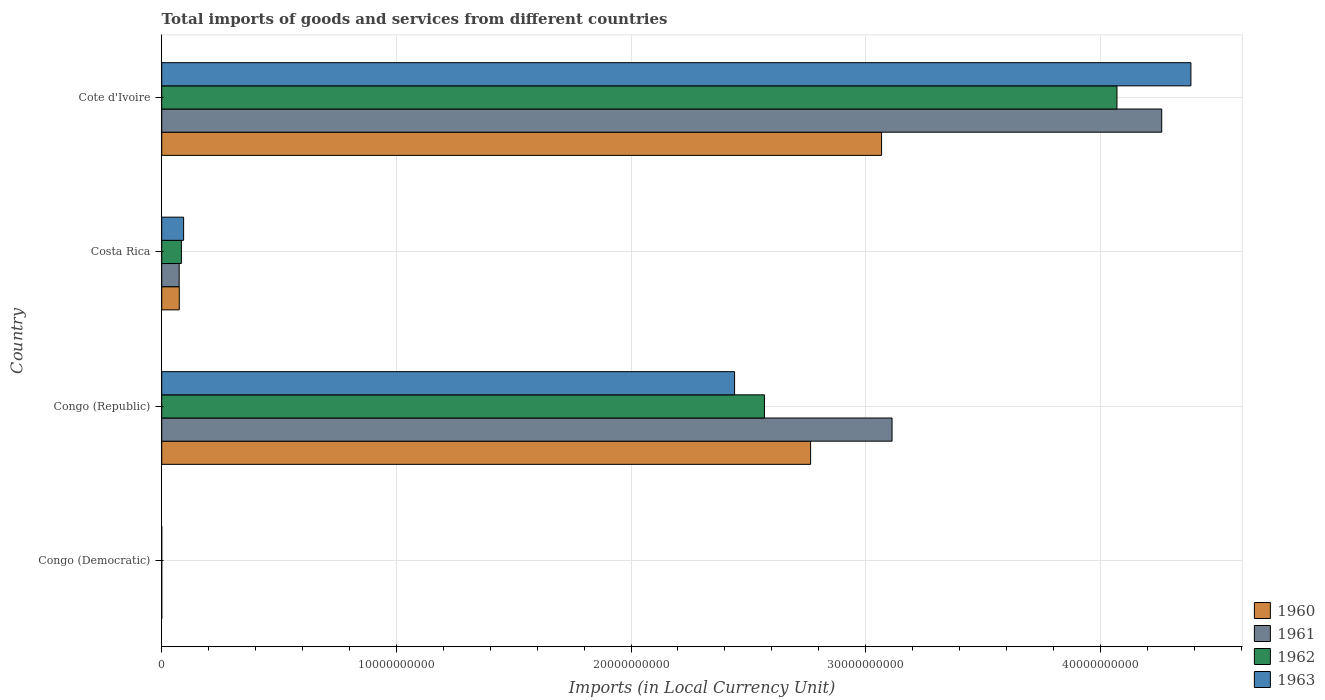How many groups of bars are there?
Your response must be concise. 4. Are the number of bars on each tick of the Y-axis equal?
Your answer should be very brief. Yes. How many bars are there on the 2nd tick from the top?
Offer a very short reply. 4. How many bars are there on the 1st tick from the bottom?
Your response must be concise. 4. What is the label of the 2nd group of bars from the top?
Your answer should be compact. Costa Rica. What is the Amount of goods and services imports in 1960 in Costa Rica?
Your answer should be very brief. 7.49e+08. Across all countries, what is the maximum Amount of goods and services imports in 1962?
Your response must be concise. 4.07e+1. Across all countries, what is the minimum Amount of goods and services imports in 1963?
Make the answer very short. 0. In which country was the Amount of goods and services imports in 1960 maximum?
Your answer should be compact. Cote d'Ivoire. In which country was the Amount of goods and services imports in 1963 minimum?
Offer a very short reply. Congo (Democratic). What is the total Amount of goods and services imports in 1960 in the graph?
Offer a terse response. 5.91e+1. What is the difference between the Amount of goods and services imports in 1963 in Congo (Republic) and that in Costa Rica?
Keep it short and to the point. 2.35e+1. What is the difference between the Amount of goods and services imports in 1961 in Congo (Republic) and the Amount of goods and services imports in 1962 in Costa Rica?
Ensure brevity in your answer.  3.03e+1. What is the average Amount of goods and services imports in 1960 per country?
Offer a very short reply. 1.48e+1. What is the difference between the Amount of goods and services imports in 1960 and Amount of goods and services imports in 1962 in Cote d'Ivoire?
Give a very brief answer. -1.00e+1. In how many countries, is the Amount of goods and services imports in 1960 greater than 20000000000 LCU?
Provide a short and direct response. 2. What is the ratio of the Amount of goods and services imports in 1962 in Congo (Democratic) to that in Cote d'Ivoire?
Provide a short and direct response. 1.4510167605346176e-15. Is the difference between the Amount of goods and services imports in 1960 in Congo (Republic) and Costa Rica greater than the difference between the Amount of goods and services imports in 1962 in Congo (Republic) and Costa Rica?
Your answer should be compact. Yes. What is the difference between the highest and the second highest Amount of goods and services imports in 1963?
Offer a terse response. 1.94e+1. What is the difference between the highest and the lowest Amount of goods and services imports in 1961?
Ensure brevity in your answer.  4.26e+1. In how many countries, is the Amount of goods and services imports in 1961 greater than the average Amount of goods and services imports in 1961 taken over all countries?
Keep it short and to the point. 2. What does the 1st bar from the bottom in Cote d'Ivoire represents?
Your response must be concise. 1960. How many bars are there?
Make the answer very short. 16. How many countries are there in the graph?
Offer a very short reply. 4. What is the difference between two consecutive major ticks on the X-axis?
Make the answer very short. 1.00e+1. Are the values on the major ticks of X-axis written in scientific E-notation?
Give a very brief answer. No. How are the legend labels stacked?
Ensure brevity in your answer.  Vertical. What is the title of the graph?
Your response must be concise. Total imports of goods and services from different countries. Does "1977" appear as one of the legend labels in the graph?
Offer a terse response. No. What is the label or title of the X-axis?
Make the answer very short. Imports (in Local Currency Unit). What is the label or title of the Y-axis?
Your answer should be very brief. Country. What is the Imports (in Local Currency Unit) in 1960 in Congo (Democratic)?
Offer a terse response. 0. What is the Imports (in Local Currency Unit) of 1961 in Congo (Democratic)?
Provide a short and direct response. 5.07076656504069e-5. What is the Imports (in Local Currency Unit) in 1962 in Congo (Democratic)?
Ensure brevity in your answer.  5.906629303353841e-5. What is the Imports (in Local Currency Unit) in 1963 in Congo (Democratic)?
Offer a very short reply. 0. What is the Imports (in Local Currency Unit) in 1960 in Congo (Republic)?
Offer a terse response. 2.77e+1. What is the Imports (in Local Currency Unit) of 1961 in Congo (Republic)?
Provide a succinct answer. 3.11e+1. What is the Imports (in Local Currency Unit) of 1962 in Congo (Republic)?
Make the answer very short. 2.57e+1. What is the Imports (in Local Currency Unit) of 1963 in Congo (Republic)?
Provide a succinct answer. 2.44e+1. What is the Imports (in Local Currency Unit) of 1960 in Costa Rica?
Your answer should be very brief. 7.49e+08. What is the Imports (in Local Currency Unit) in 1961 in Costa Rica?
Provide a short and direct response. 7.44e+08. What is the Imports (in Local Currency Unit) of 1962 in Costa Rica?
Make the answer very short. 8.40e+08. What is the Imports (in Local Currency Unit) of 1963 in Costa Rica?
Your answer should be compact. 9.34e+08. What is the Imports (in Local Currency Unit) in 1960 in Cote d'Ivoire?
Offer a very short reply. 3.07e+1. What is the Imports (in Local Currency Unit) of 1961 in Cote d'Ivoire?
Make the answer very short. 4.26e+1. What is the Imports (in Local Currency Unit) of 1962 in Cote d'Ivoire?
Give a very brief answer. 4.07e+1. What is the Imports (in Local Currency Unit) of 1963 in Cote d'Ivoire?
Your answer should be compact. 4.39e+1. Across all countries, what is the maximum Imports (in Local Currency Unit) of 1960?
Provide a short and direct response. 3.07e+1. Across all countries, what is the maximum Imports (in Local Currency Unit) in 1961?
Your answer should be very brief. 4.26e+1. Across all countries, what is the maximum Imports (in Local Currency Unit) of 1962?
Ensure brevity in your answer.  4.07e+1. Across all countries, what is the maximum Imports (in Local Currency Unit) of 1963?
Your answer should be very brief. 4.39e+1. Across all countries, what is the minimum Imports (in Local Currency Unit) in 1960?
Your answer should be compact. 0. Across all countries, what is the minimum Imports (in Local Currency Unit) in 1961?
Make the answer very short. 5.07076656504069e-5. Across all countries, what is the minimum Imports (in Local Currency Unit) of 1962?
Ensure brevity in your answer.  5.906629303353841e-5. Across all countries, what is the minimum Imports (in Local Currency Unit) of 1963?
Your response must be concise. 0. What is the total Imports (in Local Currency Unit) in 1960 in the graph?
Your answer should be compact. 5.91e+1. What is the total Imports (in Local Currency Unit) in 1961 in the graph?
Give a very brief answer. 7.45e+1. What is the total Imports (in Local Currency Unit) in 1962 in the graph?
Keep it short and to the point. 6.72e+1. What is the total Imports (in Local Currency Unit) in 1963 in the graph?
Ensure brevity in your answer.  6.92e+1. What is the difference between the Imports (in Local Currency Unit) of 1960 in Congo (Democratic) and that in Congo (Republic)?
Give a very brief answer. -2.77e+1. What is the difference between the Imports (in Local Currency Unit) of 1961 in Congo (Democratic) and that in Congo (Republic)?
Keep it short and to the point. -3.11e+1. What is the difference between the Imports (in Local Currency Unit) in 1962 in Congo (Democratic) and that in Congo (Republic)?
Your answer should be very brief. -2.57e+1. What is the difference between the Imports (in Local Currency Unit) of 1963 in Congo (Democratic) and that in Congo (Republic)?
Your answer should be compact. -2.44e+1. What is the difference between the Imports (in Local Currency Unit) in 1960 in Congo (Democratic) and that in Costa Rica?
Provide a succinct answer. -7.49e+08. What is the difference between the Imports (in Local Currency Unit) of 1961 in Congo (Democratic) and that in Costa Rica?
Give a very brief answer. -7.44e+08. What is the difference between the Imports (in Local Currency Unit) of 1962 in Congo (Democratic) and that in Costa Rica?
Provide a succinct answer. -8.40e+08. What is the difference between the Imports (in Local Currency Unit) of 1963 in Congo (Democratic) and that in Costa Rica?
Provide a succinct answer. -9.34e+08. What is the difference between the Imports (in Local Currency Unit) of 1960 in Congo (Democratic) and that in Cote d'Ivoire?
Provide a succinct answer. -3.07e+1. What is the difference between the Imports (in Local Currency Unit) of 1961 in Congo (Democratic) and that in Cote d'Ivoire?
Provide a short and direct response. -4.26e+1. What is the difference between the Imports (in Local Currency Unit) in 1962 in Congo (Democratic) and that in Cote d'Ivoire?
Provide a short and direct response. -4.07e+1. What is the difference between the Imports (in Local Currency Unit) in 1963 in Congo (Democratic) and that in Cote d'Ivoire?
Your answer should be very brief. -4.39e+1. What is the difference between the Imports (in Local Currency Unit) of 1960 in Congo (Republic) and that in Costa Rica?
Your response must be concise. 2.69e+1. What is the difference between the Imports (in Local Currency Unit) of 1961 in Congo (Republic) and that in Costa Rica?
Give a very brief answer. 3.04e+1. What is the difference between the Imports (in Local Currency Unit) in 1962 in Congo (Republic) and that in Costa Rica?
Provide a succinct answer. 2.48e+1. What is the difference between the Imports (in Local Currency Unit) of 1963 in Congo (Republic) and that in Costa Rica?
Your answer should be compact. 2.35e+1. What is the difference between the Imports (in Local Currency Unit) of 1960 in Congo (Republic) and that in Cote d'Ivoire?
Your response must be concise. -3.02e+09. What is the difference between the Imports (in Local Currency Unit) of 1961 in Congo (Republic) and that in Cote d'Ivoire?
Your answer should be compact. -1.15e+1. What is the difference between the Imports (in Local Currency Unit) of 1962 in Congo (Republic) and that in Cote d'Ivoire?
Offer a terse response. -1.50e+1. What is the difference between the Imports (in Local Currency Unit) of 1963 in Congo (Republic) and that in Cote d'Ivoire?
Give a very brief answer. -1.94e+1. What is the difference between the Imports (in Local Currency Unit) of 1960 in Costa Rica and that in Cote d'Ivoire?
Make the answer very short. -2.99e+1. What is the difference between the Imports (in Local Currency Unit) of 1961 in Costa Rica and that in Cote d'Ivoire?
Offer a very short reply. -4.19e+1. What is the difference between the Imports (in Local Currency Unit) of 1962 in Costa Rica and that in Cote d'Ivoire?
Your response must be concise. -3.99e+1. What is the difference between the Imports (in Local Currency Unit) of 1963 in Costa Rica and that in Cote d'Ivoire?
Keep it short and to the point. -4.29e+1. What is the difference between the Imports (in Local Currency Unit) in 1960 in Congo (Democratic) and the Imports (in Local Currency Unit) in 1961 in Congo (Republic)?
Give a very brief answer. -3.11e+1. What is the difference between the Imports (in Local Currency Unit) in 1960 in Congo (Democratic) and the Imports (in Local Currency Unit) in 1962 in Congo (Republic)?
Keep it short and to the point. -2.57e+1. What is the difference between the Imports (in Local Currency Unit) of 1960 in Congo (Democratic) and the Imports (in Local Currency Unit) of 1963 in Congo (Republic)?
Make the answer very short. -2.44e+1. What is the difference between the Imports (in Local Currency Unit) in 1961 in Congo (Democratic) and the Imports (in Local Currency Unit) in 1962 in Congo (Republic)?
Your response must be concise. -2.57e+1. What is the difference between the Imports (in Local Currency Unit) of 1961 in Congo (Democratic) and the Imports (in Local Currency Unit) of 1963 in Congo (Republic)?
Provide a short and direct response. -2.44e+1. What is the difference between the Imports (in Local Currency Unit) of 1962 in Congo (Democratic) and the Imports (in Local Currency Unit) of 1963 in Congo (Republic)?
Your answer should be very brief. -2.44e+1. What is the difference between the Imports (in Local Currency Unit) of 1960 in Congo (Democratic) and the Imports (in Local Currency Unit) of 1961 in Costa Rica?
Provide a succinct answer. -7.44e+08. What is the difference between the Imports (in Local Currency Unit) in 1960 in Congo (Democratic) and the Imports (in Local Currency Unit) in 1962 in Costa Rica?
Ensure brevity in your answer.  -8.40e+08. What is the difference between the Imports (in Local Currency Unit) of 1960 in Congo (Democratic) and the Imports (in Local Currency Unit) of 1963 in Costa Rica?
Your answer should be compact. -9.34e+08. What is the difference between the Imports (in Local Currency Unit) of 1961 in Congo (Democratic) and the Imports (in Local Currency Unit) of 1962 in Costa Rica?
Provide a short and direct response. -8.40e+08. What is the difference between the Imports (in Local Currency Unit) in 1961 in Congo (Democratic) and the Imports (in Local Currency Unit) in 1963 in Costa Rica?
Provide a short and direct response. -9.34e+08. What is the difference between the Imports (in Local Currency Unit) of 1962 in Congo (Democratic) and the Imports (in Local Currency Unit) of 1963 in Costa Rica?
Make the answer very short. -9.34e+08. What is the difference between the Imports (in Local Currency Unit) in 1960 in Congo (Democratic) and the Imports (in Local Currency Unit) in 1961 in Cote d'Ivoire?
Provide a short and direct response. -4.26e+1. What is the difference between the Imports (in Local Currency Unit) of 1960 in Congo (Democratic) and the Imports (in Local Currency Unit) of 1962 in Cote d'Ivoire?
Provide a succinct answer. -4.07e+1. What is the difference between the Imports (in Local Currency Unit) in 1960 in Congo (Democratic) and the Imports (in Local Currency Unit) in 1963 in Cote d'Ivoire?
Provide a short and direct response. -4.39e+1. What is the difference between the Imports (in Local Currency Unit) of 1961 in Congo (Democratic) and the Imports (in Local Currency Unit) of 1962 in Cote d'Ivoire?
Give a very brief answer. -4.07e+1. What is the difference between the Imports (in Local Currency Unit) of 1961 in Congo (Democratic) and the Imports (in Local Currency Unit) of 1963 in Cote d'Ivoire?
Offer a very short reply. -4.39e+1. What is the difference between the Imports (in Local Currency Unit) in 1962 in Congo (Democratic) and the Imports (in Local Currency Unit) in 1963 in Cote d'Ivoire?
Ensure brevity in your answer.  -4.39e+1. What is the difference between the Imports (in Local Currency Unit) of 1960 in Congo (Republic) and the Imports (in Local Currency Unit) of 1961 in Costa Rica?
Keep it short and to the point. 2.69e+1. What is the difference between the Imports (in Local Currency Unit) of 1960 in Congo (Republic) and the Imports (in Local Currency Unit) of 1962 in Costa Rica?
Give a very brief answer. 2.68e+1. What is the difference between the Imports (in Local Currency Unit) in 1960 in Congo (Republic) and the Imports (in Local Currency Unit) in 1963 in Costa Rica?
Give a very brief answer. 2.67e+1. What is the difference between the Imports (in Local Currency Unit) in 1961 in Congo (Republic) and the Imports (in Local Currency Unit) in 1962 in Costa Rica?
Offer a very short reply. 3.03e+1. What is the difference between the Imports (in Local Currency Unit) in 1961 in Congo (Republic) and the Imports (in Local Currency Unit) in 1963 in Costa Rica?
Give a very brief answer. 3.02e+1. What is the difference between the Imports (in Local Currency Unit) in 1962 in Congo (Republic) and the Imports (in Local Currency Unit) in 1963 in Costa Rica?
Ensure brevity in your answer.  2.48e+1. What is the difference between the Imports (in Local Currency Unit) of 1960 in Congo (Republic) and the Imports (in Local Currency Unit) of 1961 in Cote d'Ivoire?
Ensure brevity in your answer.  -1.50e+1. What is the difference between the Imports (in Local Currency Unit) of 1960 in Congo (Republic) and the Imports (in Local Currency Unit) of 1962 in Cote d'Ivoire?
Provide a short and direct response. -1.31e+1. What is the difference between the Imports (in Local Currency Unit) of 1960 in Congo (Republic) and the Imports (in Local Currency Unit) of 1963 in Cote d'Ivoire?
Offer a terse response. -1.62e+1. What is the difference between the Imports (in Local Currency Unit) in 1961 in Congo (Republic) and the Imports (in Local Currency Unit) in 1962 in Cote d'Ivoire?
Ensure brevity in your answer.  -9.58e+09. What is the difference between the Imports (in Local Currency Unit) in 1961 in Congo (Republic) and the Imports (in Local Currency Unit) in 1963 in Cote d'Ivoire?
Offer a very short reply. -1.27e+1. What is the difference between the Imports (in Local Currency Unit) of 1962 in Congo (Republic) and the Imports (in Local Currency Unit) of 1963 in Cote d'Ivoire?
Offer a very short reply. -1.82e+1. What is the difference between the Imports (in Local Currency Unit) of 1960 in Costa Rica and the Imports (in Local Currency Unit) of 1961 in Cote d'Ivoire?
Make the answer very short. -4.19e+1. What is the difference between the Imports (in Local Currency Unit) of 1960 in Costa Rica and the Imports (in Local Currency Unit) of 1962 in Cote d'Ivoire?
Ensure brevity in your answer.  -4.00e+1. What is the difference between the Imports (in Local Currency Unit) of 1960 in Costa Rica and the Imports (in Local Currency Unit) of 1963 in Cote d'Ivoire?
Your answer should be very brief. -4.31e+1. What is the difference between the Imports (in Local Currency Unit) of 1961 in Costa Rica and the Imports (in Local Currency Unit) of 1962 in Cote d'Ivoire?
Your answer should be very brief. -4.00e+1. What is the difference between the Imports (in Local Currency Unit) of 1961 in Costa Rica and the Imports (in Local Currency Unit) of 1963 in Cote d'Ivoire?
Offer a very short reply. -4.31e+1. What is the difference between the Imports (in Local Currency Unit) of 1962 in Costa Rica and the Imports (in Local Currency Unit) of 1963 in Cote d'Ivoire?
Give a very brief answer. -4.30e+1. What is the average Imports (in Local Currency Unit) in 1960 per country?
Your answer should be very brief. 1.48e+1. What is the average Imports (in Local Currency Unit) of 1961 per country?
Your answer should be very brief. 1.86e+1. What is the average Imports (in Local Currency Unit) in 1962 per country?
Keep it short and to the point. 1.68e+1. What is the average Imports (in Local Currency Unit) in 1963 per country?
Ensure brevity in your answer.  1.73e+1. What is the difference between the Imports (in Local Currency Unit) in 1960 and Imports (in Local Currency Unit) in 1962 in Congo (Democratic)?
Your answer should be compact. 0. What is the difference between the Imports (in Local Currency Unit) in 1960 and Imports (in Local Currency Unit) in 1963 in Congo (Democratic)?
Provide a succinct answer. -0. What is the difference between the Imports (in Local Currency Unit) of 1961 and Imports (in Local Currency Unit) of 1963 in Congo (Democratic)?
Your response must be concise. -0. What is the difference between the Imports (in Local Currency Unit) in 1962 and Imports (in Local Currency Unit) in 1963 in Congo (Democratic)?
Offer a very short reply. -0. What is the difference between the Imports (in Local Currency Unit) in 1960 and Imports (in Local Currency Unit) in 1961 in Congo (Republic)?
Your response must be concise. -3.47e+09. What is the difference between the Imports (in Local Currency Unit) of 1960 and Imports (in Local Currency Unit) of 1962 in Congo (Republic)?
Keep it short and to the point. 1.97e+09. What is the difference between the Imports (in Local Currency Unit) in 1960 and Imports (in Local Currency Unit) in 1963 in Congo (Republic)?
Your response must be concise. 3.24e+09. What is the difference between the Imports (in Local Currency Unit) in 1961 and Imports (in Local Currency Unit) in 1962 in Congo (Republic)?
Provide a succinct answer. 5.44e+09. What is the difference between the Imports (in Local Currency Unit) of 1961 and Imports (in Local Currency Unit) of 1963 in Congo (Republic)?
Offer a terse response. 6.71e+09. What is the difference between the Imports (in Local Currency Unit) in 1962 and Imports (in Local Currency Unit) in 1963 in Congo (Republic)?
Make the answer very short. 1.27e+09. What is the difference between the Imports (in Local Currency Unit) in 1960 and Imports (in Local Currency Unit) in 1961 in Costa Rica?
Offer a terse response. 4.80e+06. What is the difference between the Imports (in Local Currency Unit) in 1960 and Imports (in Local Currency Unit) in 1962 in Costa Rica?
Provide a short and direct response. -9.07e+07. What is the difference between the Imports (in Local Currency Unit) of 1960 and Imports (in Local Currency Unit) of 1963 in Costa Rica?
Offer a terse response. -1.85e+08. What is the difference between the Imports (in Local Currency Unit) of 1961 and Imports (in Local Currency Unit) of 1962 in Costa Rica?
Your answer should be very brief. -9.55e+07. What is the difference between the Imports (in Local Currency Unit) in 1961 and Imports (in Local Currency Unit) in 1963 in Costa Rica?
Provide a succinct answer. -1.90e+08. What is the difference between the Imports (in Local Currency Unit) of 1962 and Imports (in Local Currency Unit) of 1963 in Costa Rica?
Provide a succinct answer. -9.44e+07. What is the difference between the Imports (in Local Currency Unit) of 1960 and Imports (in Local Currency Unit) of 1961 in Cote d'Ivoire?
Your response must be concise. -1.19e+1. What is the difference between the Imports (in Local Currency Unit) of 1960 and Imports (in Local Currency Unit) of 1962 in Cote d'Ivoire?
Provide a short and direct response. -1.00e+1. What is the difference between the Imports (in Local Currency Unit) in 1960 and Imports (in Local Currency Unit) in 1963 in Cote d'Ivoire?
Offer a very short reply. -1.32e+1. What is the difference between the Imports (in Local Currency Unit) in 1961 and Imports (in Local Currency Unit) in 1962 in Cote d'Ivoire?
Offer a very short reply. 1.91e+09. What is the difference between the Imports (in Local Currency Unit) in 1961 and Imports (in Local Currency Unit) in 1963 in Cote d'Ivoire?
Provide a succinct answer. -1.24e+09. What is the difference between the Imports (in Local Currency Unit) of 1962 and Imports (in Local Currency Unit) of 1963 in Cote d'Ivoire?
Your answer should be compact. -3.15e+09. What is the ratio of the Imports (in Local Currency Unit) in 1963 in Congo (Democratic) to that in Congo (Republic)?
Keep it short and to the point. 0. What is the ratio of the Imports (in Local Currency Unit) in 1960 in Congo (Democratic) to that in Costa Rica?
Keep it short and to the point. 0. What is the ratio of the Imports (in Local Currency Unit) of 1961 in Congo (Democratic) to that in Costa Rica?
Give a very brief answer. 0. What is the ratio of the Imports (in Local Currency Unit) in 1963 in Congo (Democratic) to that in Costa Rica?
Ensure brevity in your answer.  0. What is the ratio of the Imports (in Local Currency Unit) of 1960 in Congo (Democratic) to that in Cote d'Ivoire?
Ensure brevity in your answer.  0. What is the ratio of the Imports (in Local Currency Unit) of 1961 in Congo (Democratic) to that in Cote d'Ivoire?
Your answer should be very brief. 0. What is the ratio of the Imports (in Local Currency Unit) in 1962 in Congo (Democratic) to that in Cote d'Ivoire?
Provide a succinct answer. 0. What is the ratio of the Imports (in Local Currency Unit) in 1963 in Congo (Democratic) to that in Cote d'Ivoire?
Offer a very short reply. 0. What is the ratio of the Imports (in Local Currency Unit) of 1960 in Congo (Republic) to that in Costa Rica?
Provide a short and direct response. 36.93. What is the ratio of the Imports (in Local Currency Unit) in 1961 in Congo (Republic) to that in Costa Rica?
Offer a very short reply. 41.83. What is the ratio of the Imports (in Local Currency Unit) of 1962 in Congo (Republic) to that in Costa Rica?
Provide a succinct answer. 30.59. What is the ratio of the Imports (in Local Currency Unit) in 1963 in Congo (Republic) to that in Costa Rica?
Offer a very short reply. 26.14. What is the ratio of the Imports (in Local Currency Unit) in 1960 in Congo (Republic) to that in Cote d'Ivoire?
Your answer should be compact. 0.9. What is the ratio of the Imports (in Local Currency Unit) of 1961 in Congo (Republic) to that in Cote d'Ivoire?
Provide a succinct answer. 0.73. What is the ratio of the Imports (in Local Currency Unit) in 1962 in Congo (Republic) to that in Cote d'Ivoire?
Your response must be concise. 0.63. What is the ratio of the Imports (in Local Currency Unit) of 1963 in Congo (Republic) to that in Cote d'Ivoire?
Keep it short and to the point. 0.56. What is the ratio of the Imports (in Local Currency Unit) in 1960 in Costa Rica to that in Cote d'Ivoire?
Your response must be concise. 0.02. What is the ratio of the Imports (in Local Currency Unit) in 1961 in Costa Rica to that in Cote d'Ivoire?
Provide a short and direct response. 0.02. What is the ratio of the Imports (in Local Currency Unit) of 1962 in Costa Rica to that in Cote d'Ivoire?
Provide a short and direct response. 0.02. What is the ratio of the Imports (in Local Currency Unit) in 1963 in Costa Rica to that in Cote d'Ivoire?
Your answer should be very brief. 0.02. What is the difference between the highest and the second highest Imports (in Local Currency Unit) in 1960?
Your answer should be compact. 3.02e+09. What is the difference between the highest and the second highest Imports (in Local Currency Unit) in 1961?
Give a very brief answer. 1.15e+1. What is the difference between the highest and the second highest Imports (in Local Currency Unit) of 1962?
Your answer should be compact. 1.50e+1. What is the difference between the highest and the second highest Imports (in Local Currency Unit) in 1963?
Provide a short and direct response. 1.94e+1. What is the difference between the highest and the lowest Imports (in Local Currency Unit) in 1960?
Your response must be concise. 3.07e+1. What is the difference between the highest and the lowest Imports (in Local Currency Unit) of 1961?
Offer a very short reply. 4.26e+1. What is the difference between the highest and the lowest Imports (in Local Currency Unit) in 1962?
Ensure brevity in your answer.  4.07e+1. What is the difference between the highest and the lowest Imports (in Local Currency Unit) of 1963?
Provide a succinct answer. 4.39e+1. 